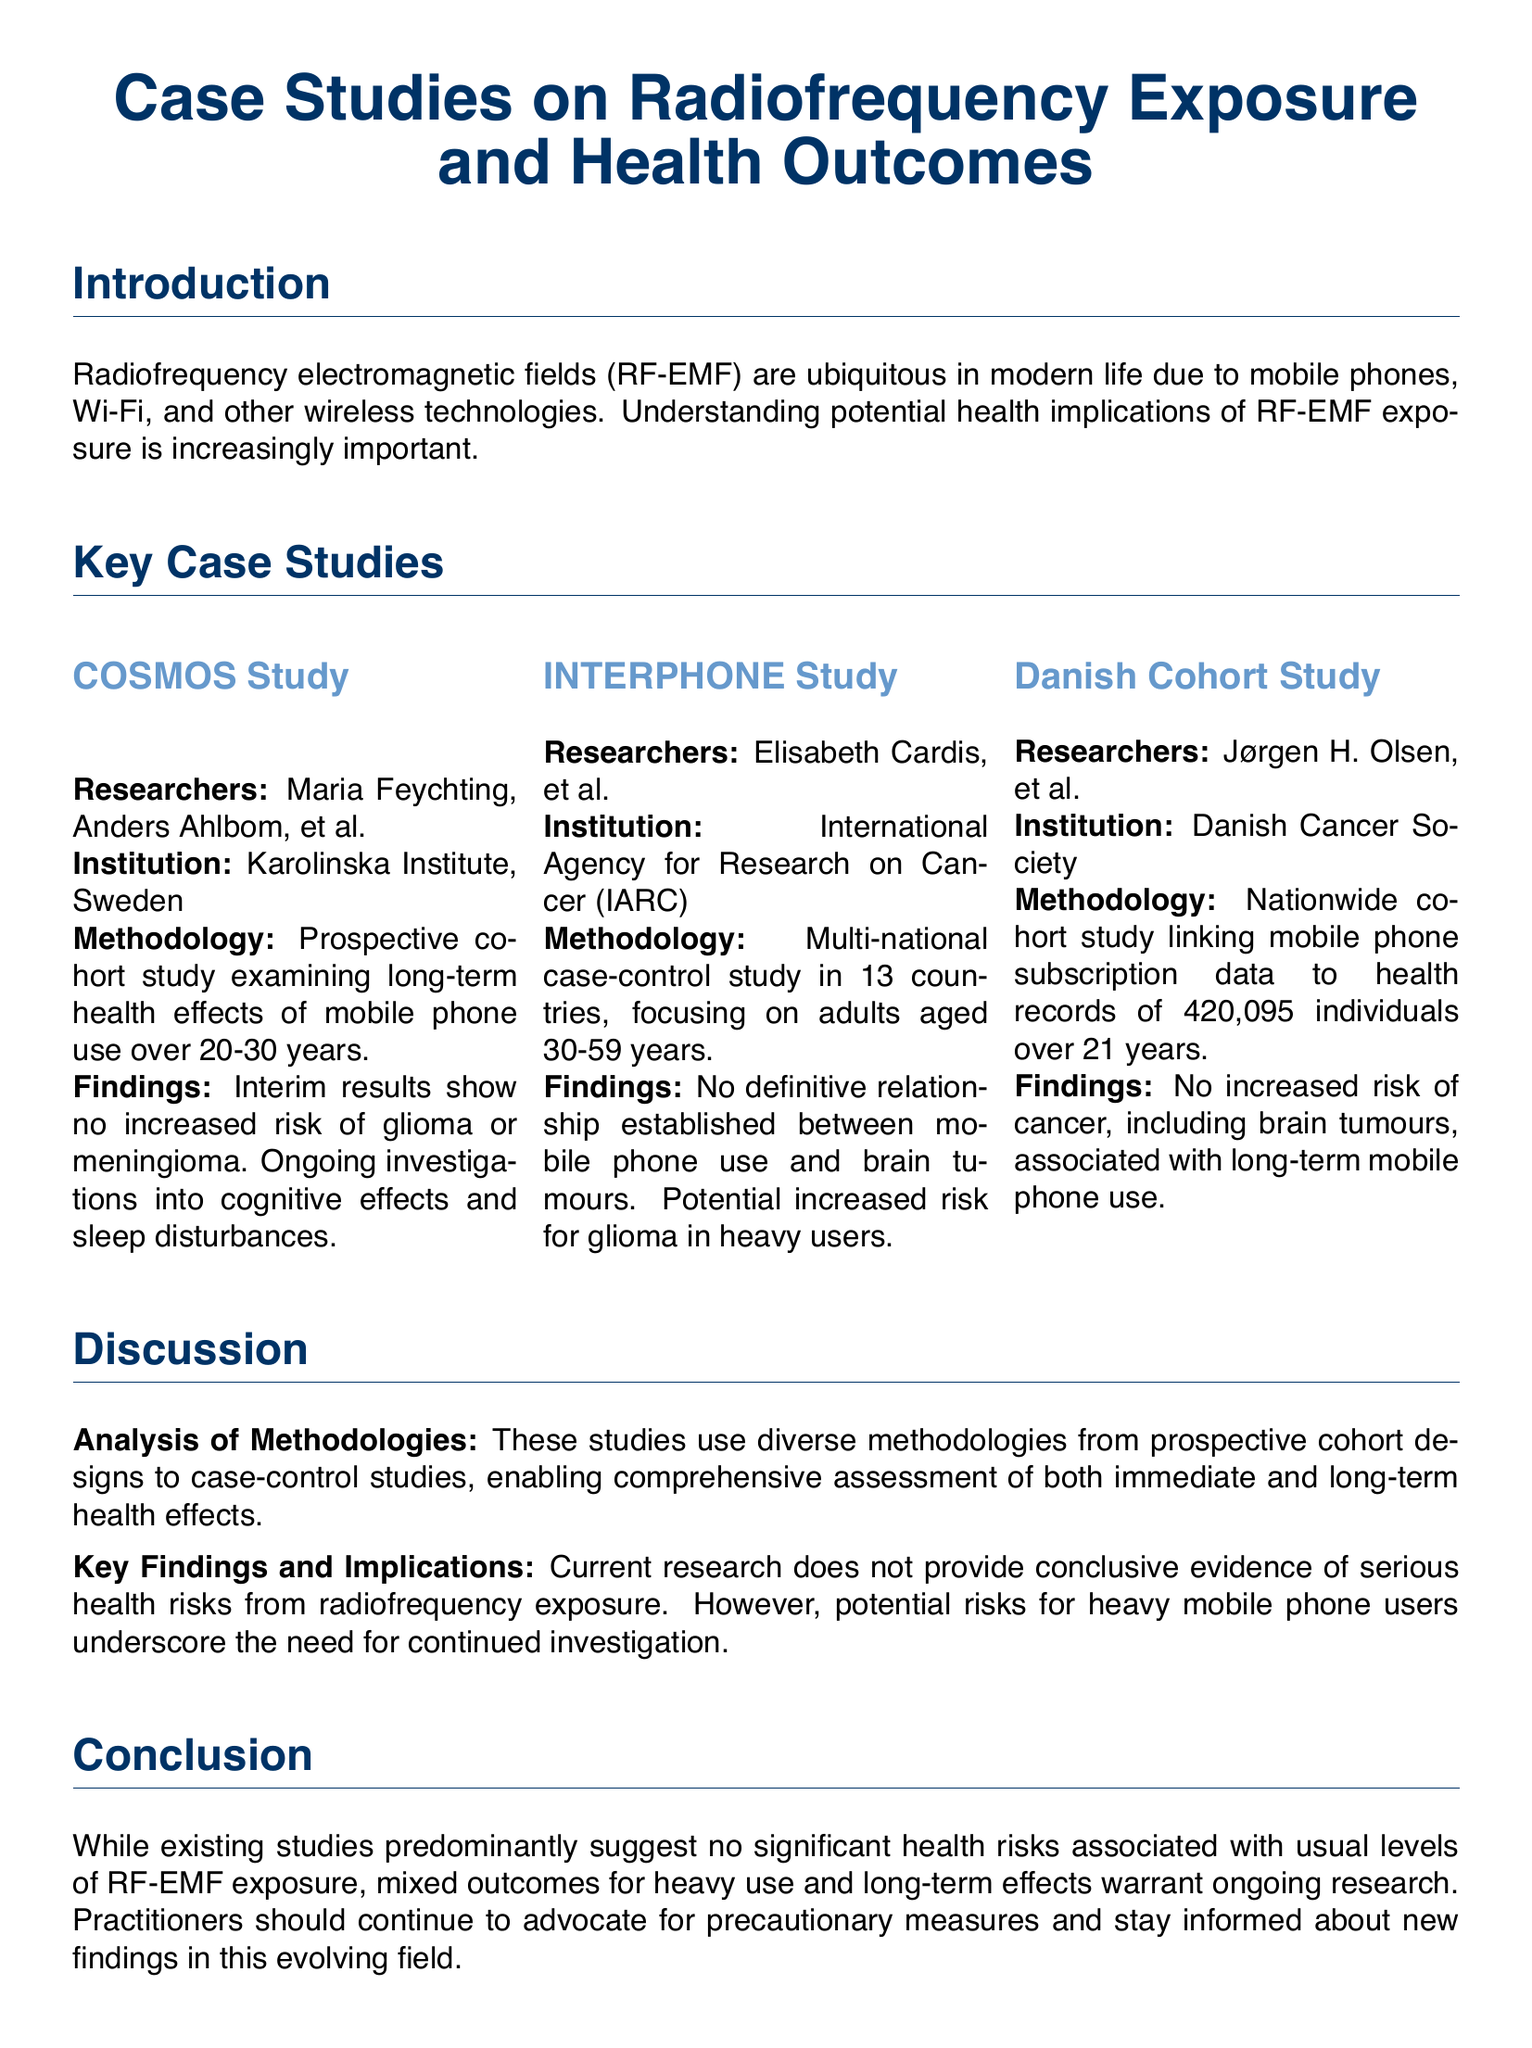What is the name of the first study mentioned? The first study mentioned is "COSMOS Study."
Answer: COSMOS Study Who conducted the INTERPHONE Study? The INTERPHONE Study was conducted by Elisabeth Cardis, et al.
Answer: Elisabeth Cardis, et al What type of study design did the COSMOS Study utilize? The COSMOS Study utilized a prospective cohort study design.
Answer: Prospective cohort study How many individuals were part of the Danish Cohort Study? The Danish Cohort Study involved 420,095 individuals.
Answer: 420,095 What was the duration of the COSMOS Study? The duration of the COSMOS Study is 20-30 years.
Answer: 20-30 years What significant health outcome was assessed in the Danish Cohort Study? The significant health outcome assessed was cancer, including brain tumours.
Answer: Cancer, including brain tumours What is the key finding of the INTERPHONE Study regarding brain tumours? The key finding is that no definitive relationship was established between mobile phone use and brain tumours.
Answer: No definitive relationship established What recommendation is made regarding heavy mobile phone use? The recommendation is to underscore the need for continued investigation.
Answer: Continued investigation What type of document is this analysis presented in? This analysis is presented in a transcript format.
Answer: Transcript 